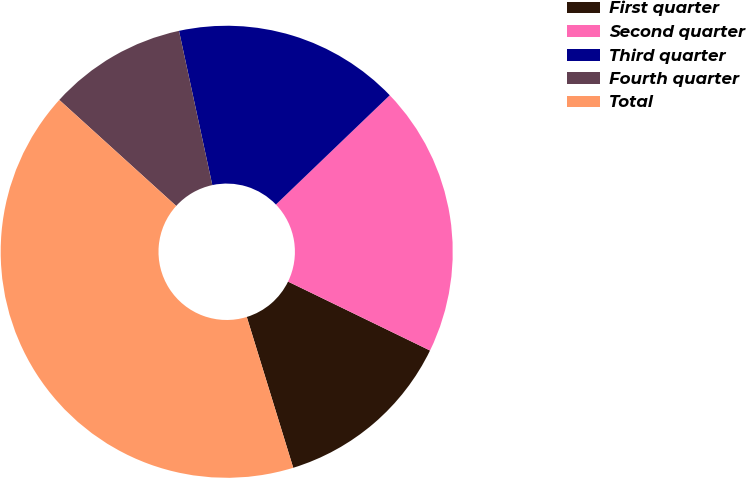<chart> <loc_0><loc_0><loc_500><loc_500><pie_chart><fcel>First quarter<fcel>Second quarter<fcel>Third quarter<fcel>Fourth quarter<fcel>Total<nl><fcel>13.05%<fcel>19.37%<fcel>16.21%<fcel>9.89%<fcel>41.48%<nl></chart> 